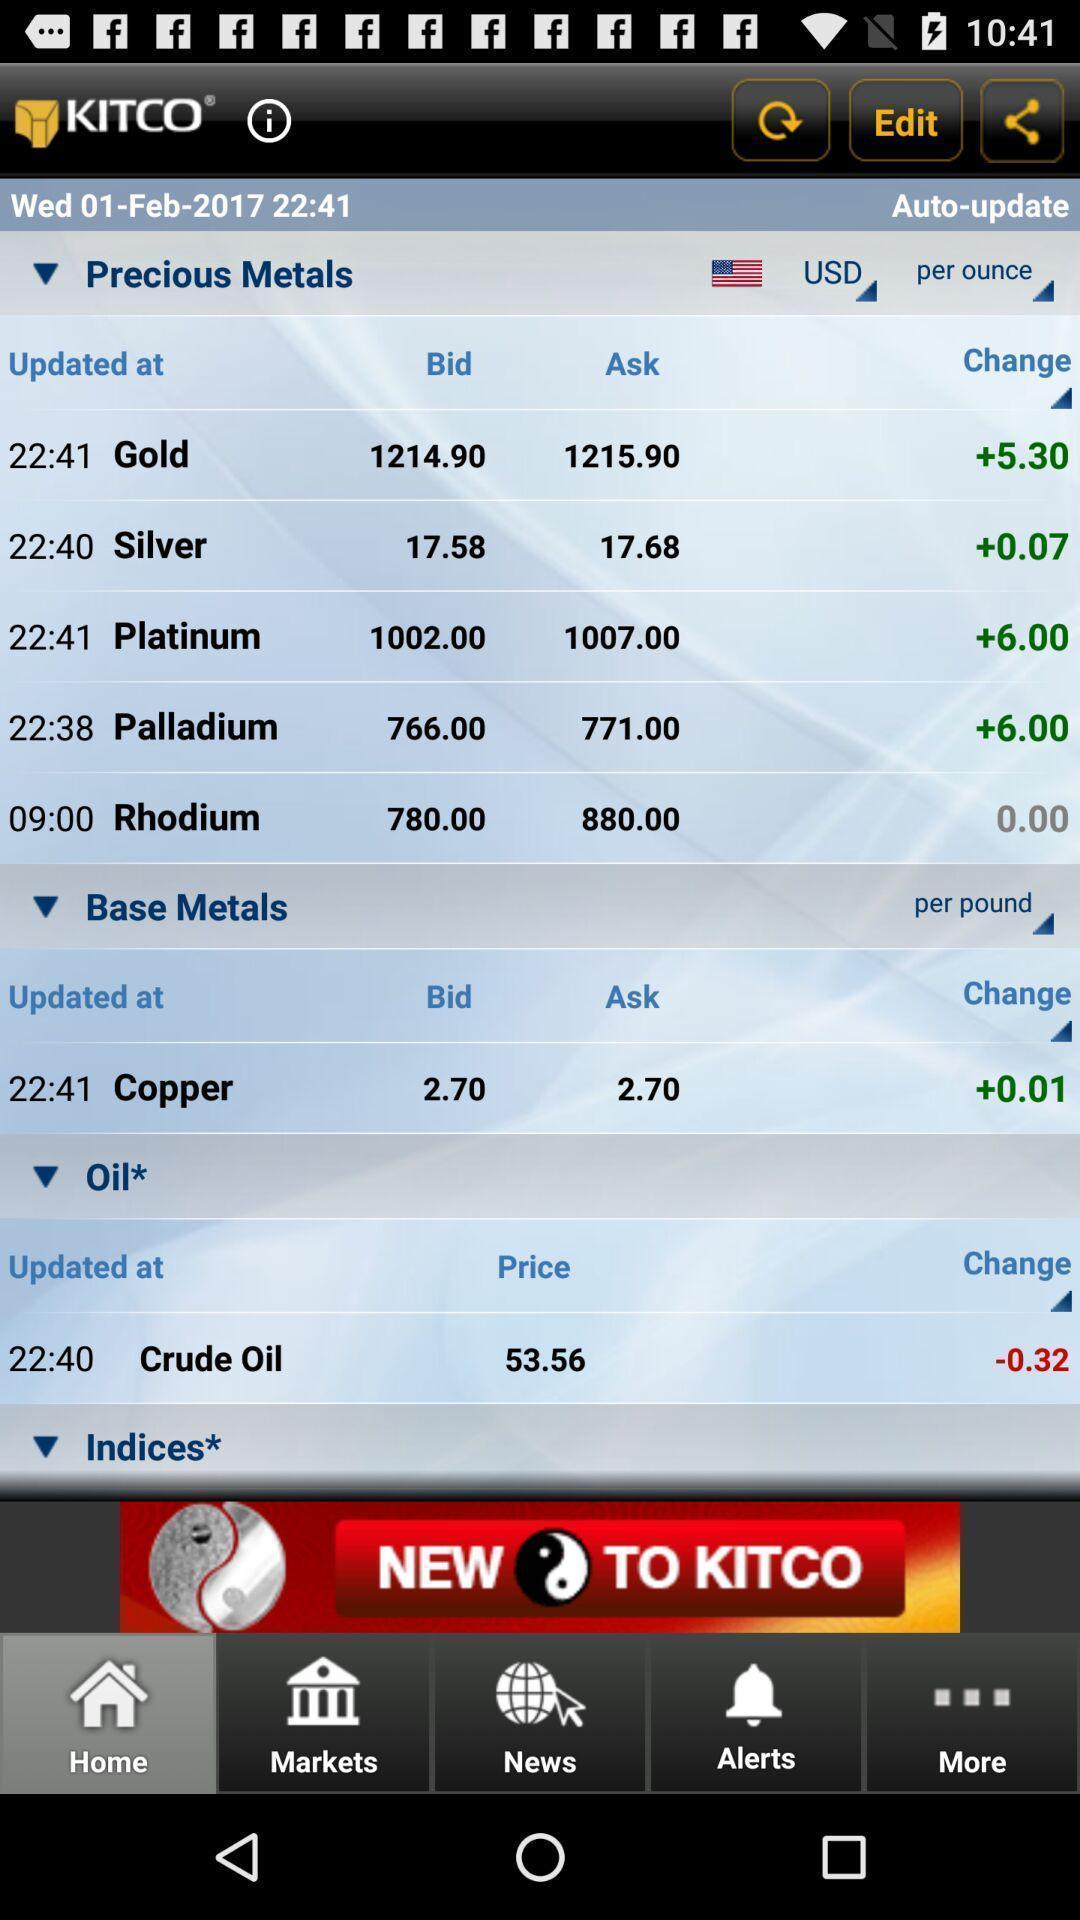Provide a description of this screenshot. Page showing info in a trading based app. 